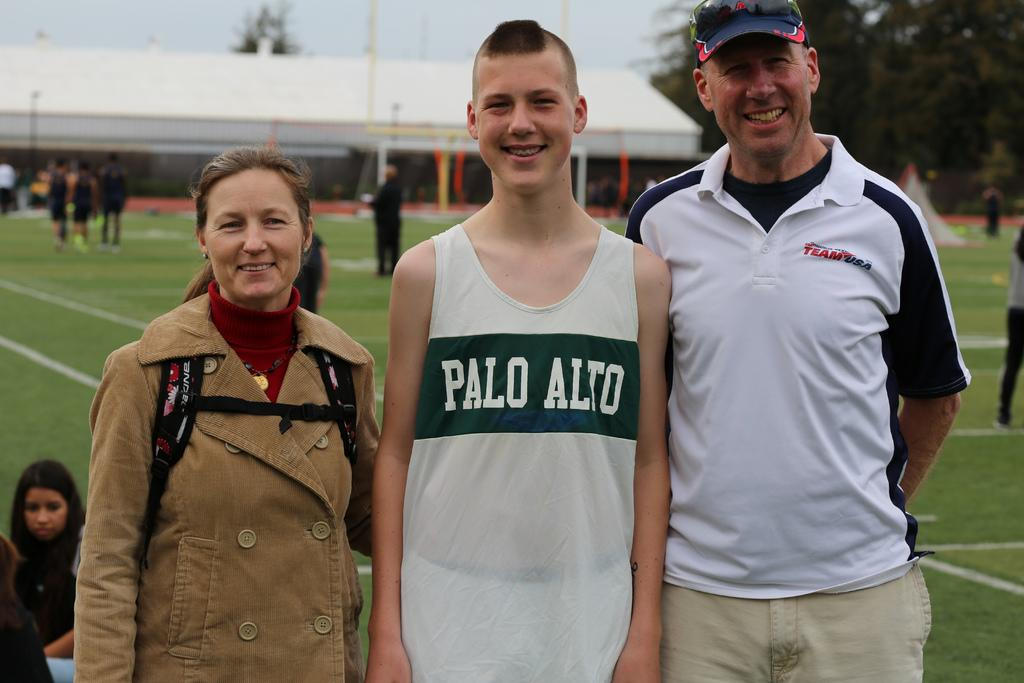<image>
Describe the image concisely. A runner for Palo Alto poses for a photo with a man and a woman. 